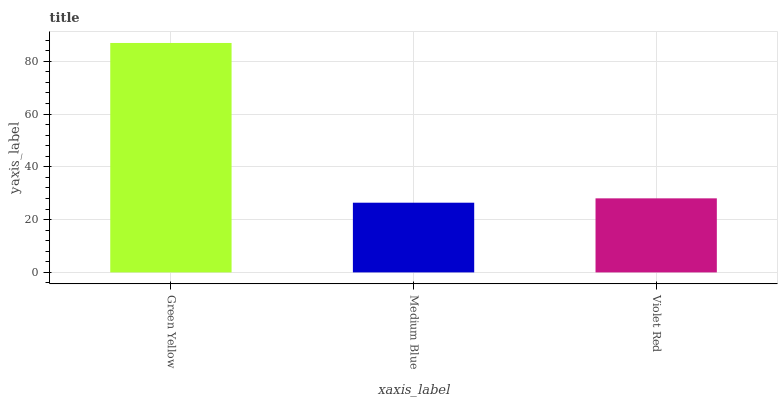Is Medium Blue the minimum?
Answer yes or no. Yes. Is Green Yellow the maximum?
Answer yes or no. Yes. Is Violet Red the minimum?
Answer yes or no. No. Is Violet Red the maximum?
Answer yes or no. No. Is Violet Red greater than Medium Blue?
Answer yes or no. Yes. Is Medium Blue less than Violet Red?
Answer yes or no. Yes. Is Medium Blue greater than Violet Red?
Answer yes or no. No. Is Violet Red less than Medium Blue?
Answer yes or no. No. Is Violet Red the high median?
Answer yes or no. Yes. Is Violet Red the low median?
Answer yes or no. Yes. Is Green Yellow the high median?
Answer yes or no. No. Is Medium Blue the low median?
Answer yes or no. No. 